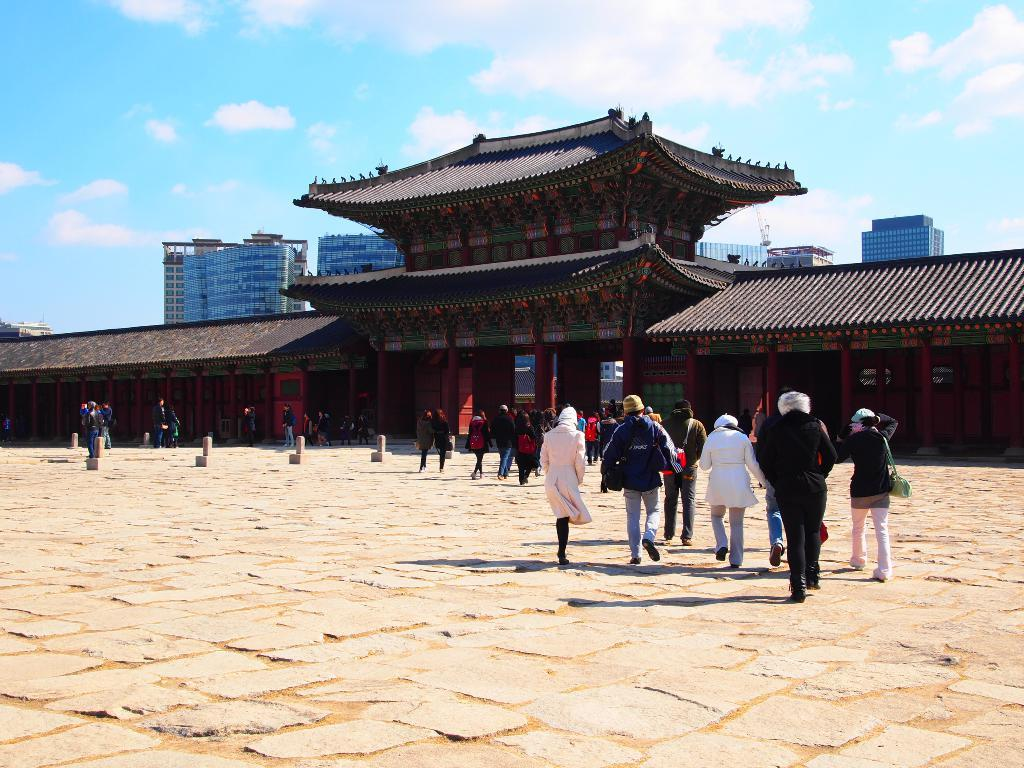What type of structures can be seen in the image? There are buildings in the image. Who or what else is present in the image? There are people in the image. What are some people wearing in the image? Some people are wearing coats in the image. What are some people carrying in the image? Some people are carrying bags in the image. What can be seen on the road in the image? There are poles on the road in the image. What is visible in the sky in the image? There are clouds in the sky in the image. What type of yam is being driven by the person in the image? There is no yam or person driving in the image. What is the end result of the situation depicted in the image? The image does not depict a specific situation or event with an end result. 